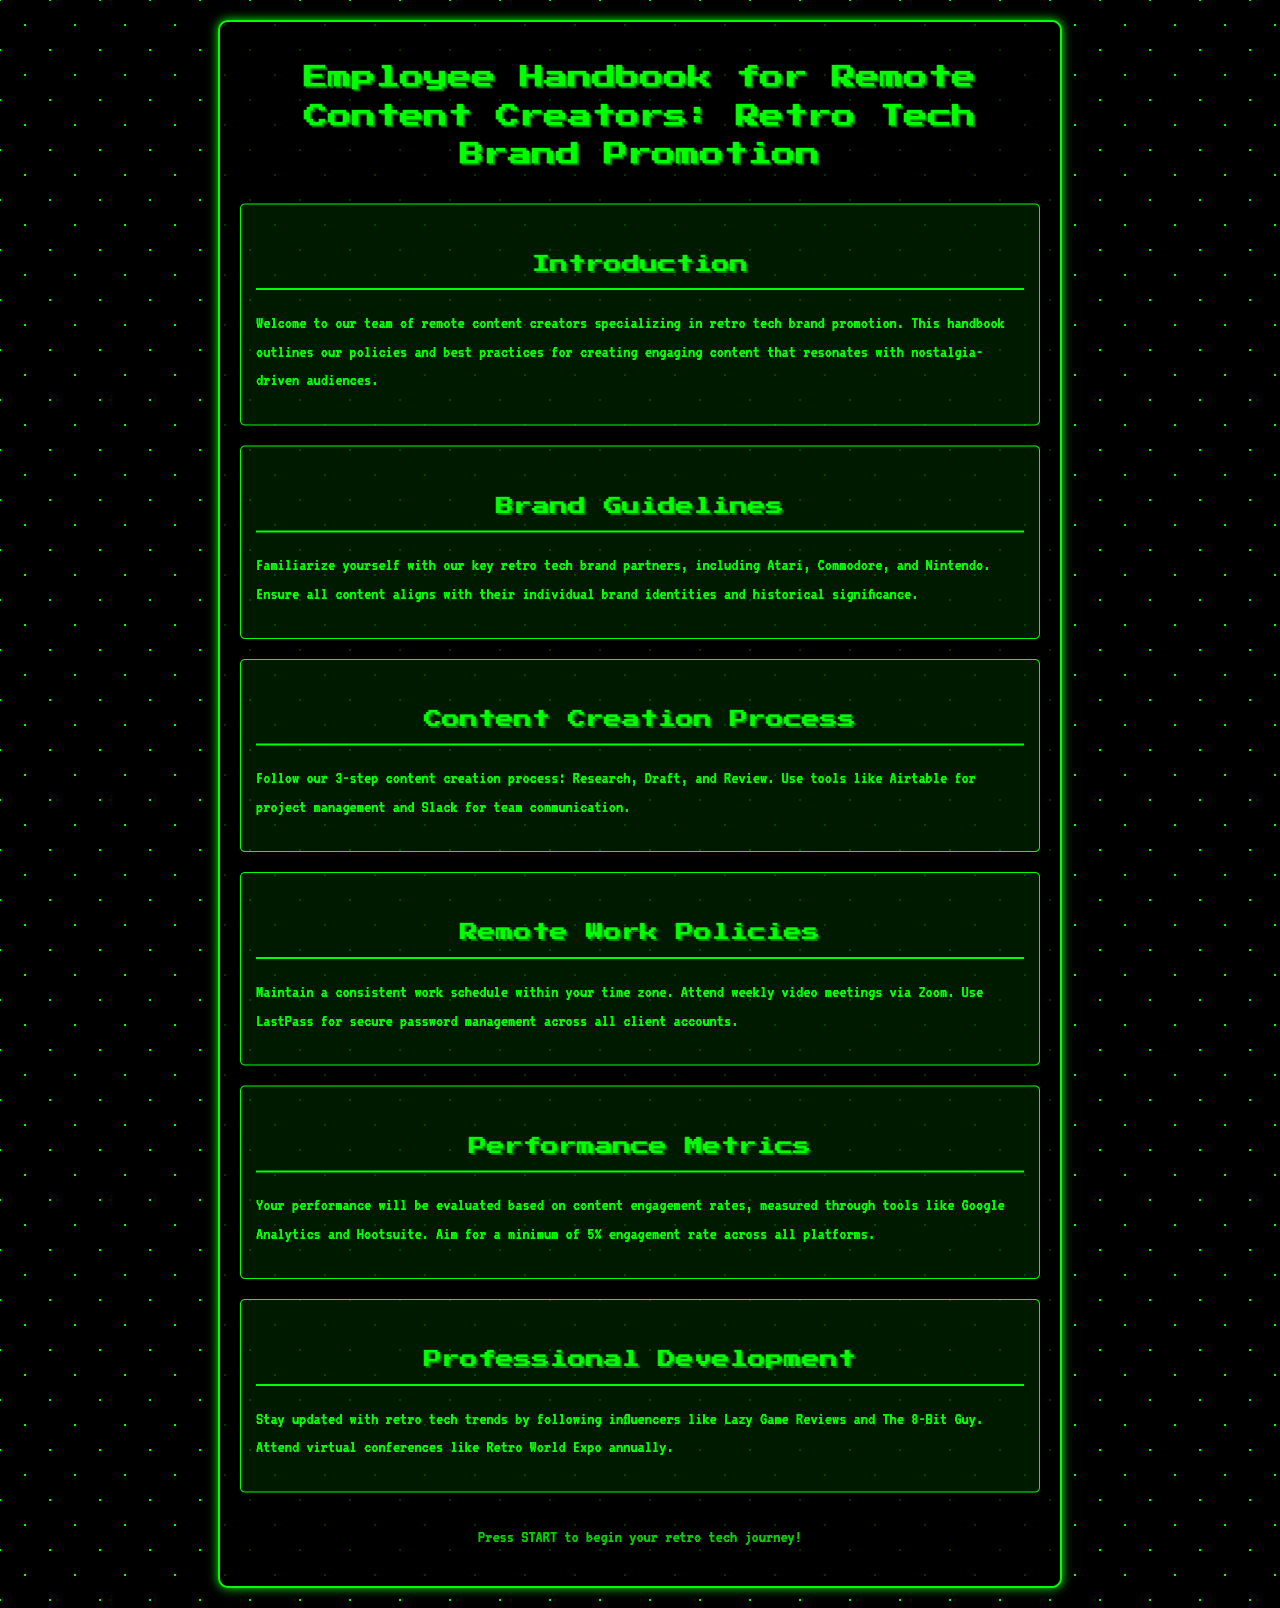What is the focus of the employee handbook? The handbook outlines policies and practices for remote content creators specializing in retro tech brand promotion.
Answer: retro tech brand promotion Who are the key retro tech brand partners mentioned? The document specifies that key partners include Atari, Commodore, and Nintendo.
Answer: Atari, Commodore, Nintendo What is the minimum engagement rate aimed for across all platforms? The document states that a minimum of 5% engagement rate is expected.
Answer: 5% Which tools are recommended for project management? The handbook suggests using Airtable for project management.
Answer: Airtable What is the video meeting platform used for weekly meetings? The document specifies that Zoom is used for weekly video meetings.
Answer: Zoom What is the first step in the content creation process? The handbook outlines a 3-step process where the first step is Research.
Answer: Research Which influencers are recommended for staying updated on retro tech trends? The document mentions Lazy Game Reviews and The 8-Bit Guy as influencers to follow.
Answer: Lazy Game Reviews, The 8-Bit Guy What is the purpose of using LastPass? The document states that LastPass is used for secure password management.
Answer: secure password management 